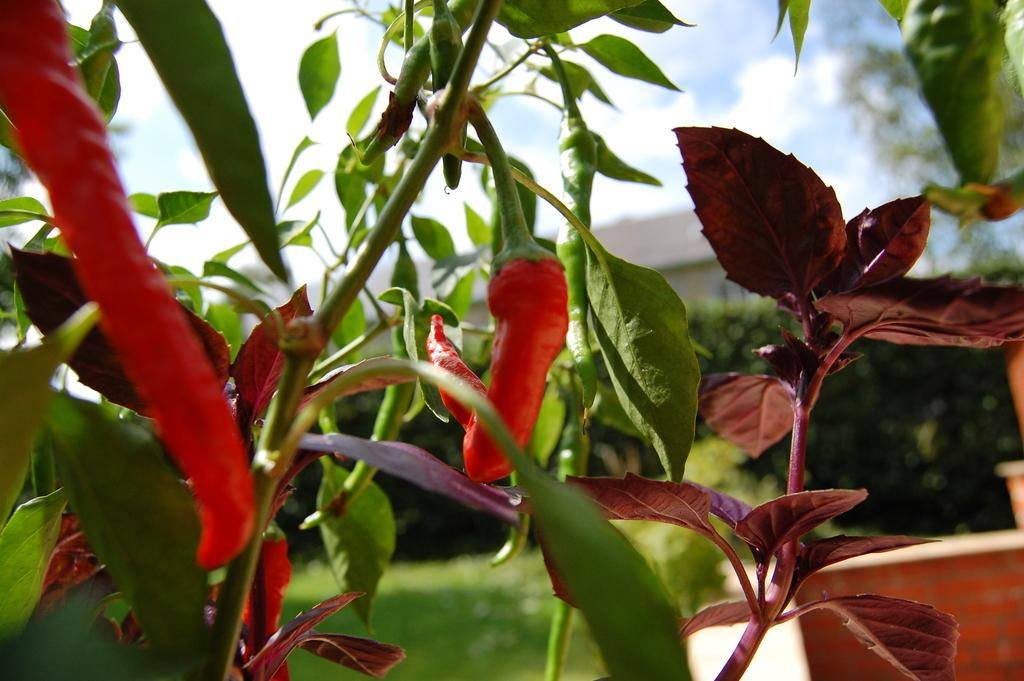What type of plant is visible in the image? There are red chilies on a plant in the image. What can be seen in the background of the image? There are hedges in the background of the image. What structure might be located behind the hedges? There appears to be a building behind the hedges. What is visible at the top of the image? The sky is visible at the top of the image. How many sisters are present in the image? There is no mention of any sisters in the image; it features red chilies on a plant, hedges, a building, and the sky. 